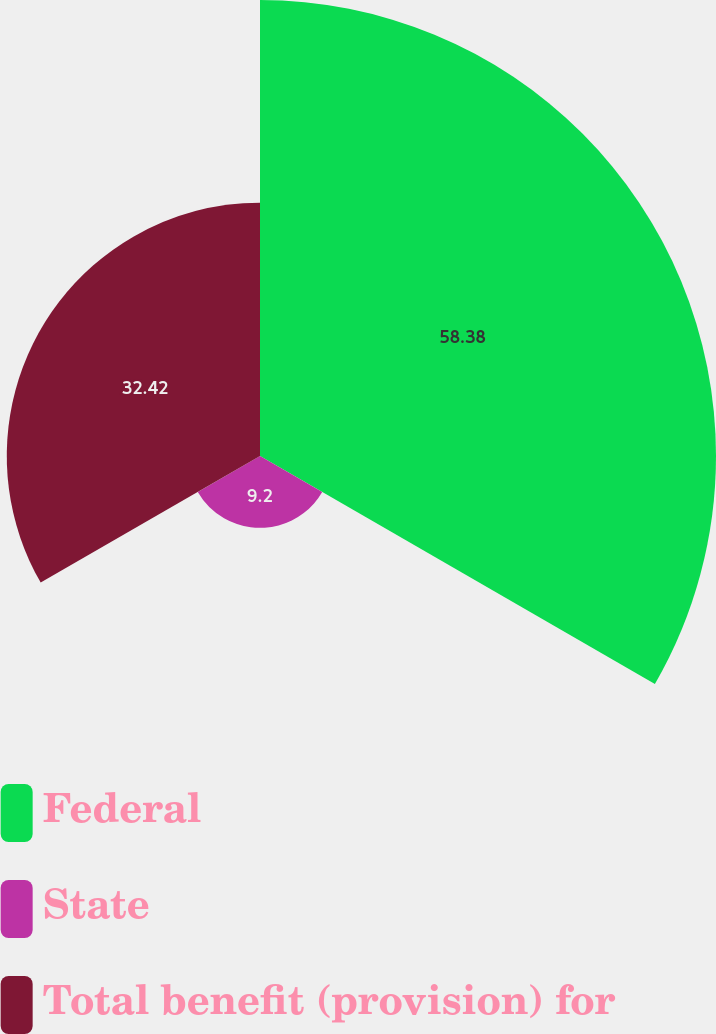Convert chart to OTSL. <chart><loc_0><loc_0><loc_500><loc_500><pie_chart><fcel>Federal<fcel>State<fcel>Total benefit (provision) for<nl><fcel>58.38%<fcel>9.2%<fcel>32.42%<nl></chart> 